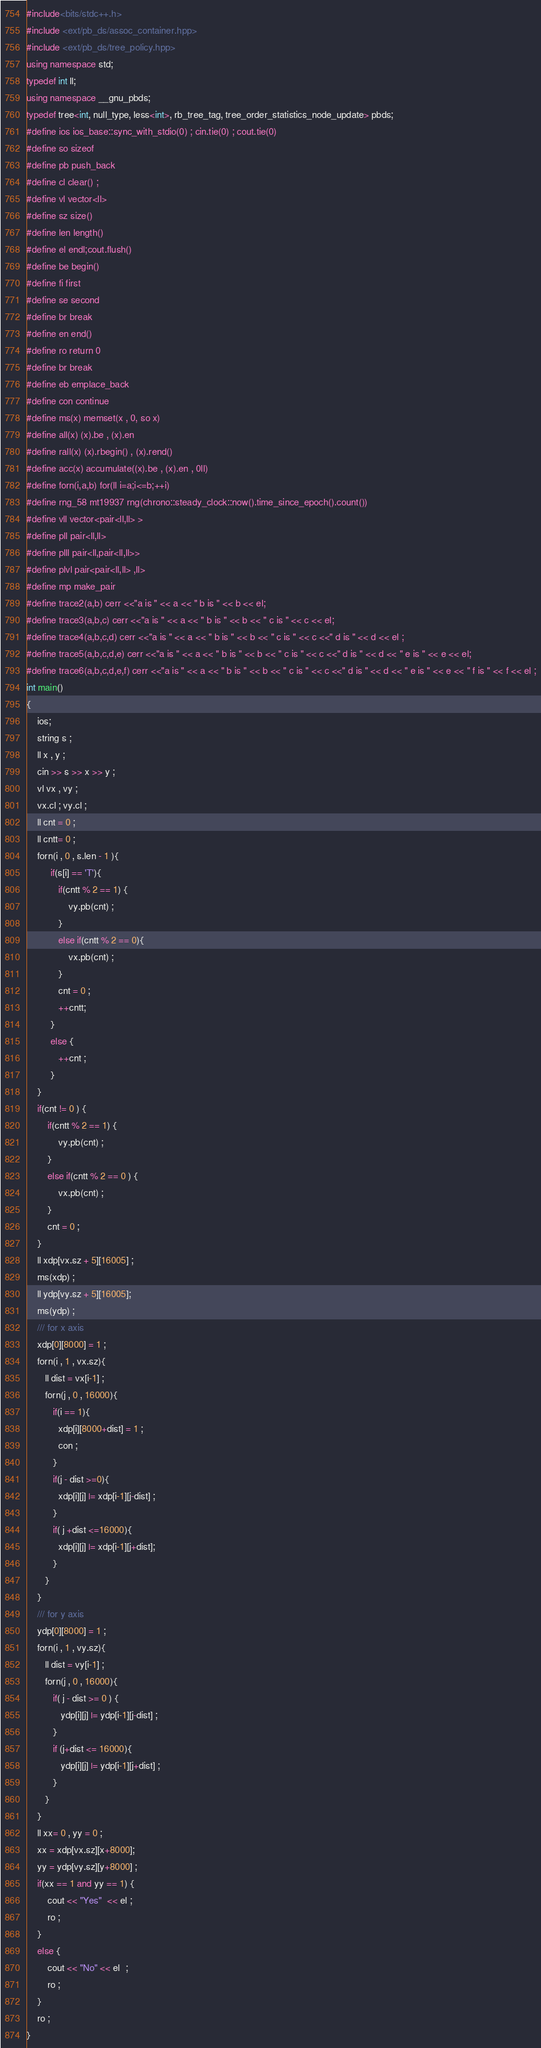Convert code to text. <code><loc_0><loc_0><loc_500><loc_500><_C++_>#include<bits/stdc++.h>
#include <ext/pb_ds/assoc_container.hpp>
#include <ext/pb_ds/tree_policy.hpp>
using namespace std;
typedef int ll;
using namespace __gnu_pbds;
typedef tree<int, null_type, less<int>, rb_tree_tag, tree_order_statistics_node_update> pbds;
#define ios ios_base::sync_with_stdio(0) ; cin.tie(0) ; cout.tie(0)
#define so sizeof
#define pb push_back
#define cl clear() ;
#define vl vector<ll>
#define sz size()
#define len length()
#define el endl;cout.flush()
#define be begin()
#define fi first
#define se second
#define br break
#define en end()
#define ro return 0
#define br break
#define eb emplace_back
#define con continue
#define ms(x) memset(x , 0, so x)
#define all(x) (x).be , (x).en
#define rall(x) (x).rbegin() , (x).rend()
#define acc(x) accumulate((x).be , (x).en , 0ll)
#define forn(i,a,b) for(ll i=a;i<=b;++i)
#define rng_58 mt19937 rng(chrono::steady_clock::now().time_since_epoch().count())
#define vll vector<pair<ll,ll> >
#define pll pair<ll,ll>
#define plll pair<ll,pair<ll,ll>>
#define plvl pair<pair<ll,ll> ,ll>
#define mp make_pair
#define trace2(a,b) cerr <<"a is " << a << " b is " << b << el;
#define trace3(a,b,c) cerr <<"a is " << a << " b is " << b << " c is " << c << el;
#define trace4(a,b,c,d) cerr <<"a is " << a << " b is " << b << " c is " << c <<" d is " << d << el ;
#define trace5(a,b,c,d,e) cerr <<"a is " << a << " b is " << b << " c is " << c <<" d is " << d << " e is " << e << el;
#define trace6(a,b,c,d,e,f) cerr <<"a is " << a << " b is " << b << " c is " << c <<" d is " << d << " e is " << e << " f is " << f << el ;
int main()
{
    ios;
    string s ;
    ll x , y ;
    cin >> s >> x >> y ;
    vl vx , vy ;
    vx.cl ; vy.cl ;
    ll cnt = 0 ;
    ll cntt= 0 ;
    forn(i , 0 , s.len - 1 ){
         if(s[i] == 'T'){
            if(cntt % 2 == 1) {
                vy.pb(cnt) ;
            }
            else if(cntt % 2 == 0){
                vx.pb(cnt) ;
            }
            cnt = 0 ;
            ++cntt;
         }
         else {
            ++cnt ;
         }
    }
    if(cnt != 0 ) {
        if(cntt % 2 == 1) {
            vy.pb(cnt) ;
        }
        else if(cntt % 2 == 0 ) {
            vx.pb(cnt) ;
        }
        cnt = 0 ;
    }
    ll xdp[vx.sz + 5][16005] ;
    ms(xdp) ;
    ll ydp[vy.sz + 5][16005];
    ms(ydp) ;
    /// for x axis
    xdp[0][8000] = 1 ;
    forn(i , 1 , vx.sz){
       ll dist = vx[i-1] ;
       forn(j , 0 , 16000){
          if(i == 1){
            xdp[i][8000+dist] = 1 ;
            con ;
          }
          if(j - dist >=0){
            xdp[i][j] |= xdp[i-1][j-dist] ;
          }
          if( j +dist <=16000){
            xdp[i][j] |= xdp[i-1][j+dist];
          }
       }
    }
    /// for y axis
    ydp[0][8000] = 1 ;
    forn(i , 1 , vy.sz){
       ll dist = vy[i-1] ;
       forn(j , 0 , 16000){
          if( j - dist >= 0 ) {
             ydp[i][j] |= ydp[i-1][j-dist] ;
          }
          if (j+dist <= 16000){
             ydp[i][j] |= ydp[i-1][j+dist] ;
          }
       }
    }
    ll xx= 0 , yy = 0 ;
    xx = xdp[vx.sz][x+8000];
    yy = ydp[vy.sz][y+8000] ;
    if(xx == 1 and yy == 1) {
        cout << "Yes"  << el ;
        ro ;
    }
    else {
        cout << "No" << el  ;
        ro ;
    }
    ro ;
}

</code> 